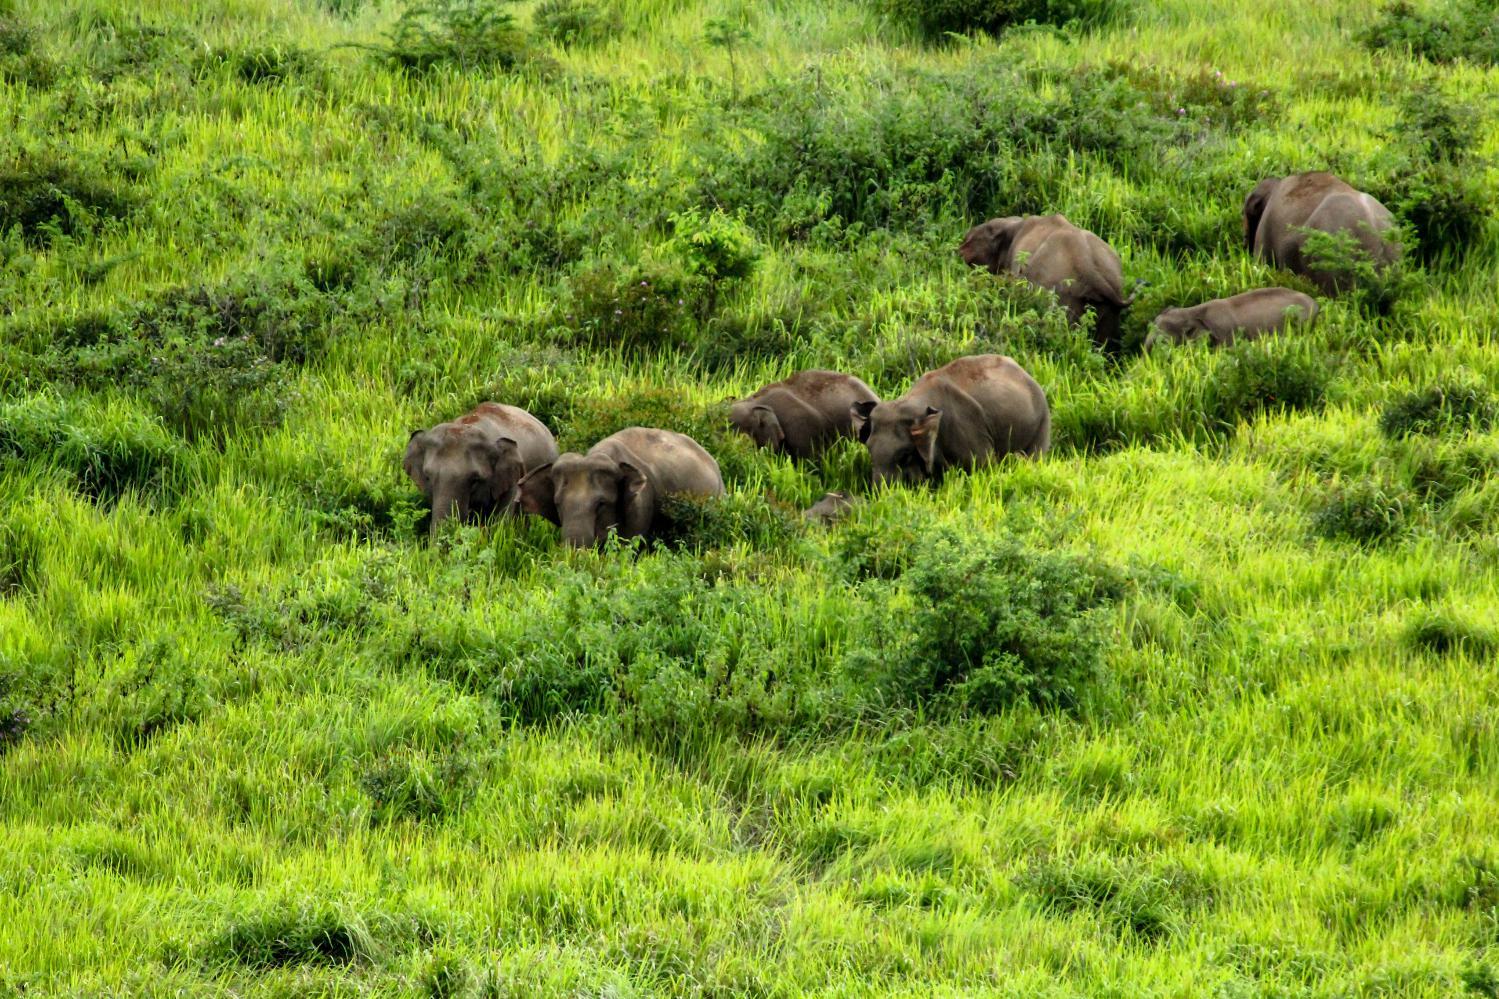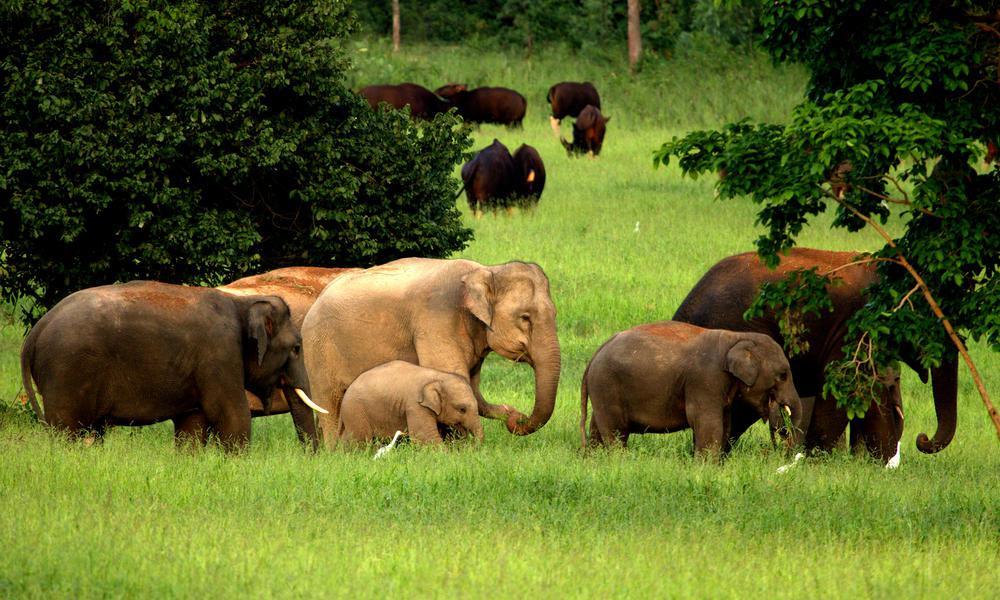The first image is the image on the left, the second image is the image on the right. For the images shown, is this caption "The elephant on the left is being attended to by humans." true? Answer yes or no. No. The first image is the image on the left, the second image is the image on the right. For the images displayed, is the sentence "The left image shows humans interacting with an elephant." factually correct? Answer yes or no. No. 